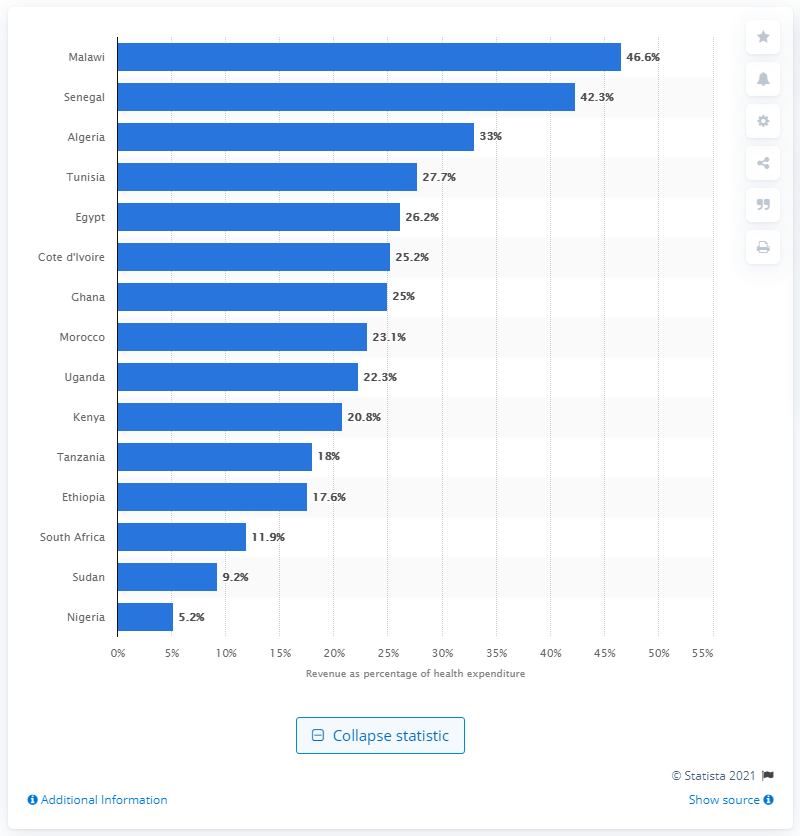Mention a couple of crucial points in this snapshot. In 2014, the pharmaceutical industry generated 20.8% of Kenya's total health expenditures. 